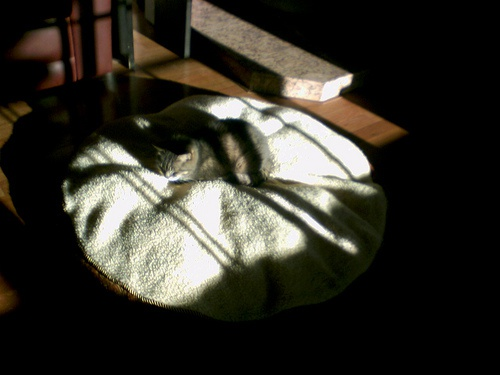Describe the objects in this image and their specific colors. I can see cat in black, gray, and darkgreen tones and chair in black, gray, and darkgreen tones in this image. 